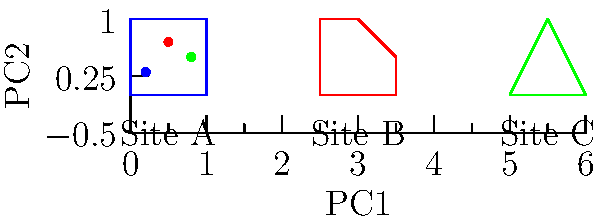Based on the shape analysis of pottery designs from three archaeological sites (A, B, and C) as shown in the figure, which two sites exhibit the highest similarity in their pottery designs according to Procrustes distance in the Principal Component (PC) space? To answer this question, we need to follow these steps:

1. Understand the concept of Procrustes analysis and Principal Component Analysis (PCA) in shape analysis:
   - Procrustes analysis aligns shapes to minimize the sum of squared distances between corresponding points.
   - PCA reduces the dimensionality of the data while preserving the most important variations.

2. Interpret the given figure:
   - The top part shows representative pottery shapes from three sites (A, B, and C).
   - The bottom part is a PCA plot, where each point represents a site's pottery shape in PC space.

3. Analyze the PCA plot:
   - The closer two points are in PC space, the more similar their shapes are.
   - PC1 (x-axis) represents the primary mode of shape variation.
   - PC2 (y-axis) represents the secondary mode of shape variation.

4. Compare the distances between points in PC space:
   - Site A (blue) and Site B (red) appear closest to each other.
   - Site C (green) is further away from both A and B.

5. Relate the PC plot to the actual shapes:
   - Sites A and B have more similar overall shapes (quadrilaterals) compared to Site C (triangle).
   - This similarity is reflected in their closer proximity in PC space.

6. Conclude based on Procrustes distance:
   - Procrustes distance is smallest between the two closest points in PC space.
   - Therefore, Sites A and B have the highest similarity according to Procrustes distance.
Answer: Sites A and B 